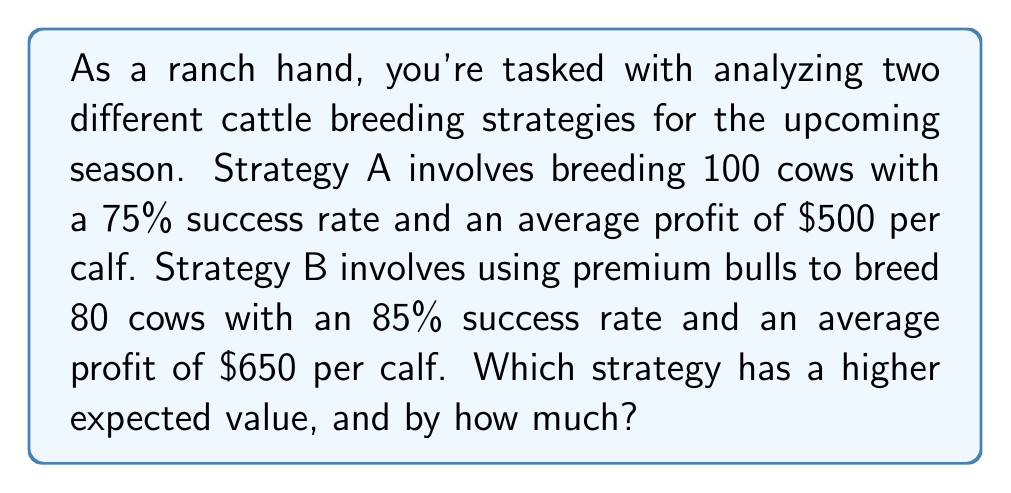Can you solve this math problem? To solve this problem, we need to calculate the expected value of each strategy and compare them.

1. Strategy A:
   - Number of cows: 100
   - Success rate: 75% = 0.75
   - Profit per calf: $500

   Expected value of Strategy A:
   $$EV_A = 100 \times 0.75 \times \$500 = \$37,500$$

2. Strategy B:
   - Number of cows: 80
   - Success rate: 85% = 0.85
   - Profit per calf: $650

   Expected value of Strategy B:
   $$EV_B = 80 \times 0.85 \times \$650 = \$44,200$$

3. Comparing the two strategies:
   Difference in expected value:
   $$\Delta EV = EV_B - EV_A = \$44,200 - \$37,500 = \$6,700$$

Strategy B has a higher expected value, and the difference is $6,700.
Answer: Strategy B has a higher expected value, exceeding Strategy A by $6,700. 